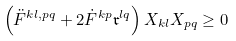<formula> <loc_0><loc_0><loc_500><loc_500>\left ( \ddot { F } ^ { k l , p q } + 2 \dot { F } ^ { k p } { \mathfrak r } ^ { l q } \right ) X _ { k l } X _ { p q } \geq 0</formula> 